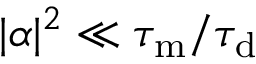Convert formula to latex. <formula><loc_0><loc_0><loc_500><loc_500>| \alpha | ^ { 2 } \ll \tau _ { m } / \tau _ { d }</formula> 